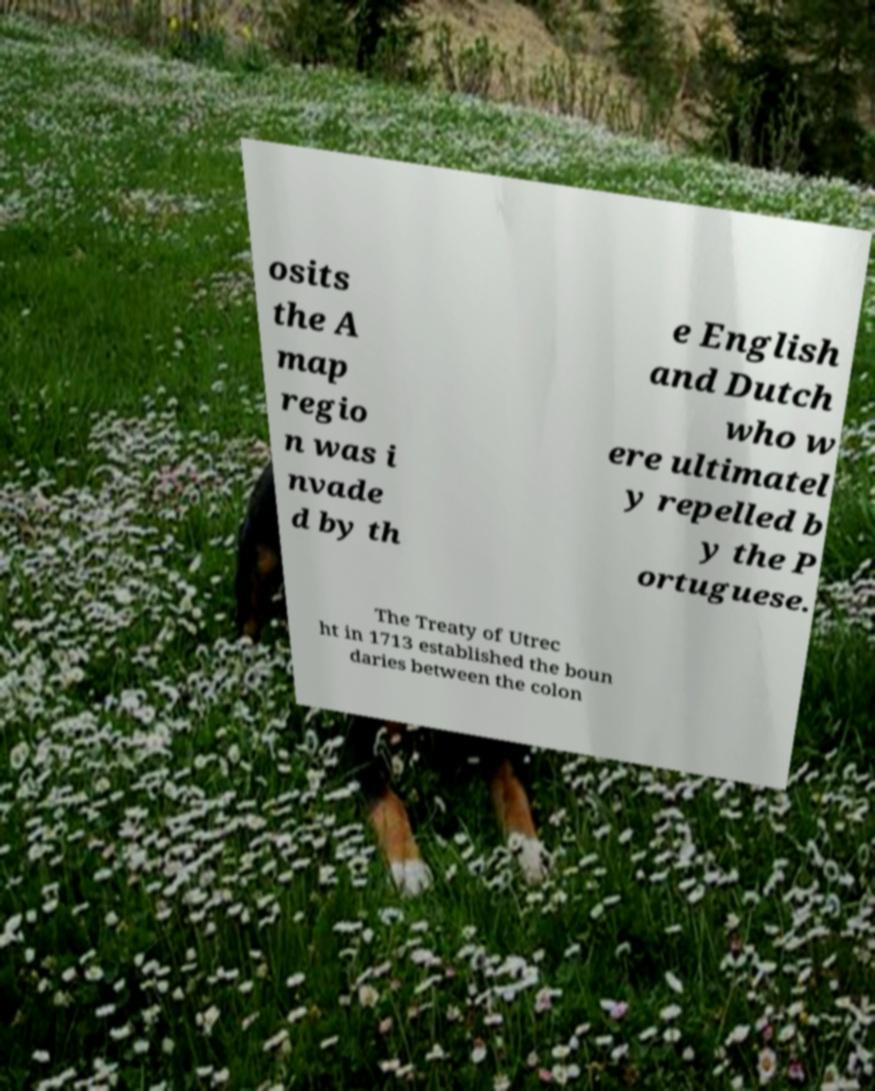Could you extract and type out the text from this image? osits the A map regio n was i nvade d by th e English and Dutch who w ere ultimatel y repelled b y the P ortuguese. The Treaty of Utrec ht in 1713 established the boun daries between the colon 